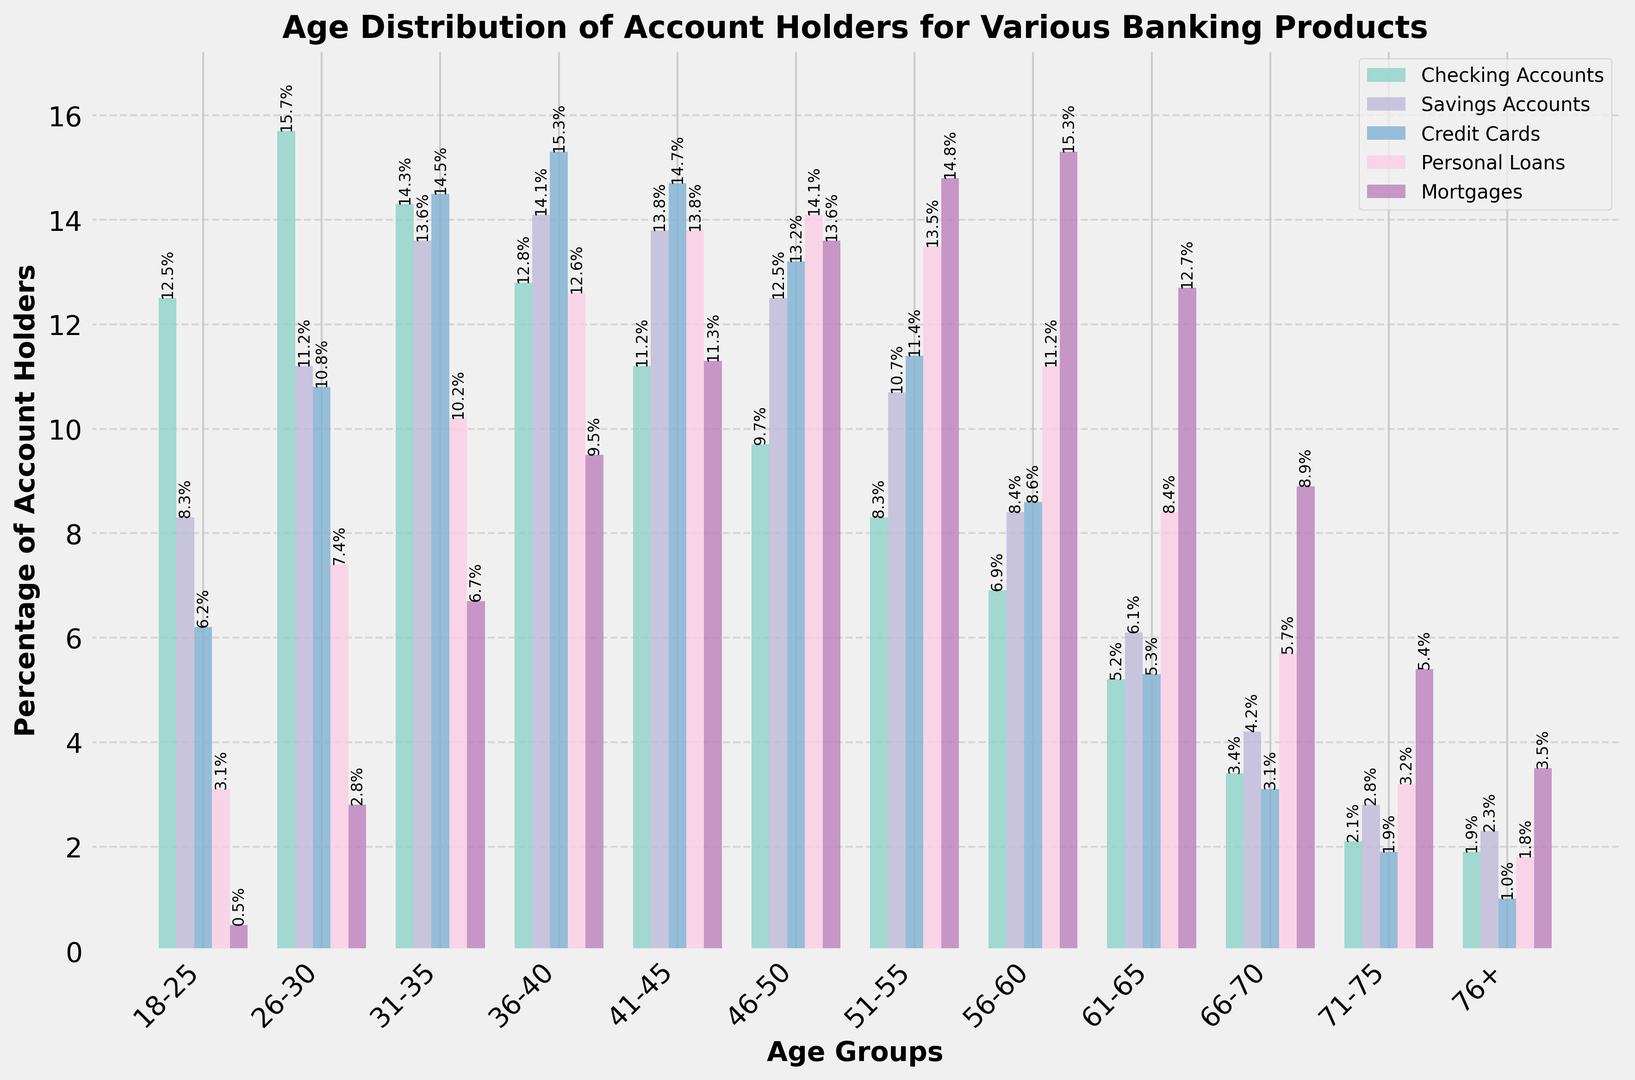What age group has the highest percentage of mortgage holders? The highest bar for the mortgage holders segment is found in the 56-60 age group, which visually stands out.
Answer: 56-60 Which product has the highest percentage in the 31-35 age group? In the 31-35 age group, the highest bar is for Credit Cards, which represents 14.5%.
Answer: Credit Cards What is the total percentage of account holders who have Personal Loans in the 41-45 age group and the 46-50 age group? The percentages of Personal Loans for 41-45 and 46-50 age groups are 13.8% and 14.1%, respectively. Adding them results in 13.8 + 14.1 = 27.9%.
Answer: 27.9% Compare the percentages of Checking Accounts holders in the 18-25 and 61-65 age groups. Which is higher? The Checking Accounts bar for 18-25 is higher at 12.5%, compared to 5.2% for the 61-65 age group.
Answer: 18-25 Which age group has the lowest percentage of Credit Card holders? The bar representing the 76+ age group is the smallest for the Credit Cards segment.
Answer: 76+ What is the average percentage of Savings Accounts holders in the 66-70 and 71-75 age groups? The percentages of Savings Account holders for the 66-70 and 71-75 age groups are 4.2% and 2.8%, respectively. The average is calculated as (4.2 + 2.8) / 2 = 3.5%.
Answer: 3.5% Is the percentage of Personal Loans holders in the 51-55 age group greater than that in the 56-60 age group? The bar for Personal Loans in the 51-55 age group shows 13.5%, while the corresponding bar in the 56-60 age group shows 11.2%. So 13.5% > 11.2%.
Answer: Yes What's the difference in percentages for Savings Accounts holders between the 26-30 and 36-40 age groups? The percentages for Savings Accounts in the 26-30 and 36-40 age groups are 11.2% and 14.1%, respectively. The difference is 14.1 - 11.2 = 2.9%.
Answer: 2.9% Which product shows a consistently increasing percentage trend from the 18-25 to the 56-60 age groups? By examining the heights of the bars for each product across these age groups, Personal Loans show a consistent increase.
Answer: Personal Loans How does the percentage of Mortgages holders in the 36-40 age group compare to that in the 46-50 age group? For Mortgages, the percentages are 9.5% in the 36-40 age group and 13.6% in the 46-50 age group. Thus, 13.6% is higher than 9.5%.
Answer: 46-50 is higher 